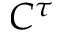Convert formula to latex. <formula><loc_0><loc_0><loc_500><loc_500>C ^ { \tau }</formula> 